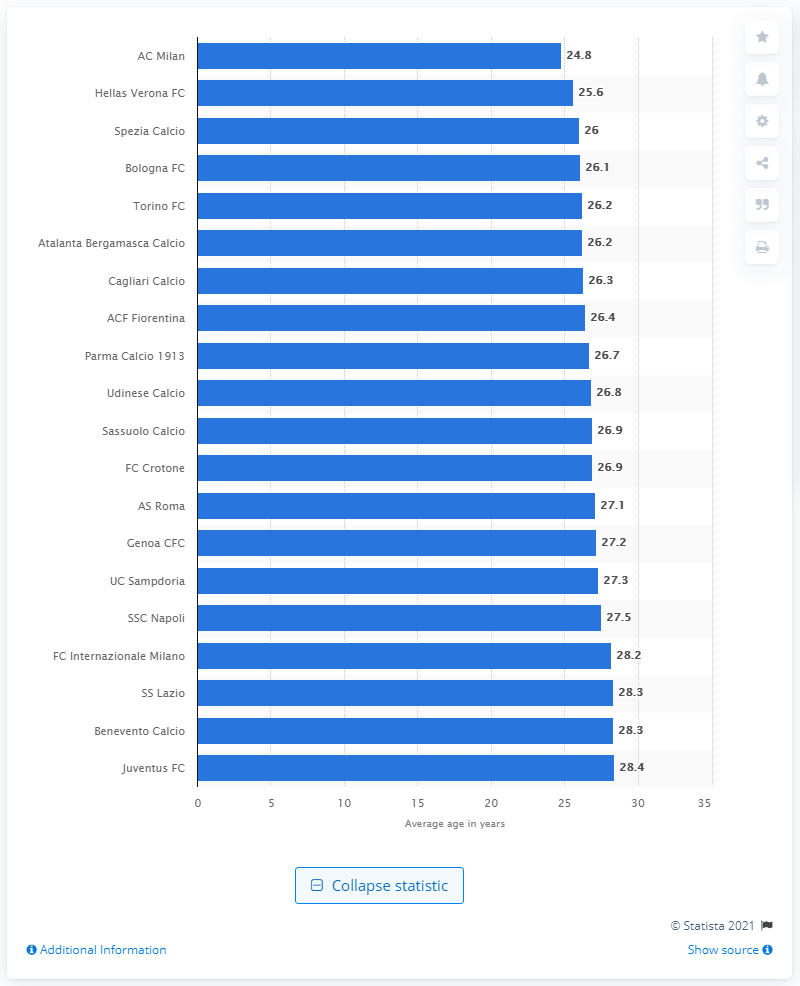Outline some significant characteristics in this image. Juventus FC had the oldest average age in the Serie A league. AC Milan was the Serie A soccer club with the youngest average age. 